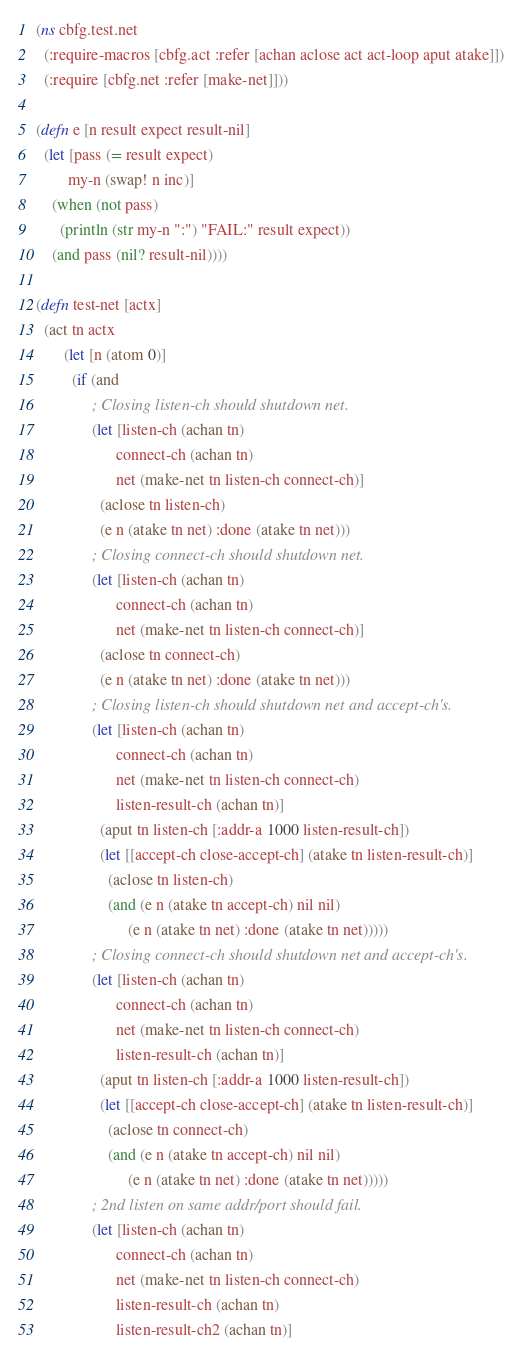<code> <loc_0><loc_0><loc_500><loc_500><_Clojure_>(ns cbfg.test.net
  (:require-macros [cbfg.act :refer [achan aclose act act-loop aput atake]])
  (:require [cbfg.net :refer [make-net]]))

(defn e [n result expect result-nil]
  (let [pass (= result expect)
        my-n (swap! n inc)]
    (when (not pass)
      (println (str my-n ":") "FAIL:" result expect))
    (and pass (nil? result-nil))))

(defn test-net [actx]
  (act tn actx
       (let [n (atom 0)]
         (if (and
              ; Closing listen-ch should shutdown net.
              (let [listen-ch (achan tn)
                    connect-ch (achan tn)
                    net (make-net tn listen-ch connect-ch)]
                (aclose tn listen-ch)
                (e n (atake tn net) :done (atake tn net)))
              ; Closing connect-ch should shutdown net.
              (let [listen-ch (achan tn)
                    connect-ch (achan tn)
                    net (make-net tn listen-ch connect-ch)]
                (aclose tn connect-ch)
                (e n (atake tn net) :done (atake tn net)))
              ; Closing listen-ch should shutdown net and accept-ch's.
              (let [listen-ch (achan tn)
                    connect-ch (achan tn)
                    net (make-net tn listen-ch connect-ch)
                    listen-result-ch (achan tn)]
                (aput tn listen-ch [:addr-a 1000 listen-result-ch])
                (let [[accept-ch close-accept-ch] (atake tn listen-result-ch)]
                  (aclose tn listen-ch)
                  (and (e n (atake tn accept-ch) nil nil)
                       (e n (atake tn net) :done (atake tn net)))))
              ; Closing connect-ch should shutdown net and accept-ch's.
              (let [listen-ch (achan tn)
                    connect-ch (achan tn)
                    net (make-net tn listen-ch connect-ch)
                    listen-result-ch (achan tn)]
                (aput tn listen-ch [:addr-a 1000 listen-result-ch])
                (let [[accept-ch close-accept-ch] (atake tn listen-result-ch)]
                  (aclose tn connect-ch)
                  (and (e n (atake tn accept-ch) nil nil)
                       (e n (atake tn net) :done (atake tn net)))))
              ; 2nd listen on same addr/port should fail.
              (let [listen-ch (achan tn)
                    connect-ch (achan tn)
                    net (make-net tn listen-ch connect-ch)
                    listen-result-ch (achan tn)
                    listen-result-ch2 (achan tn)]</code> 